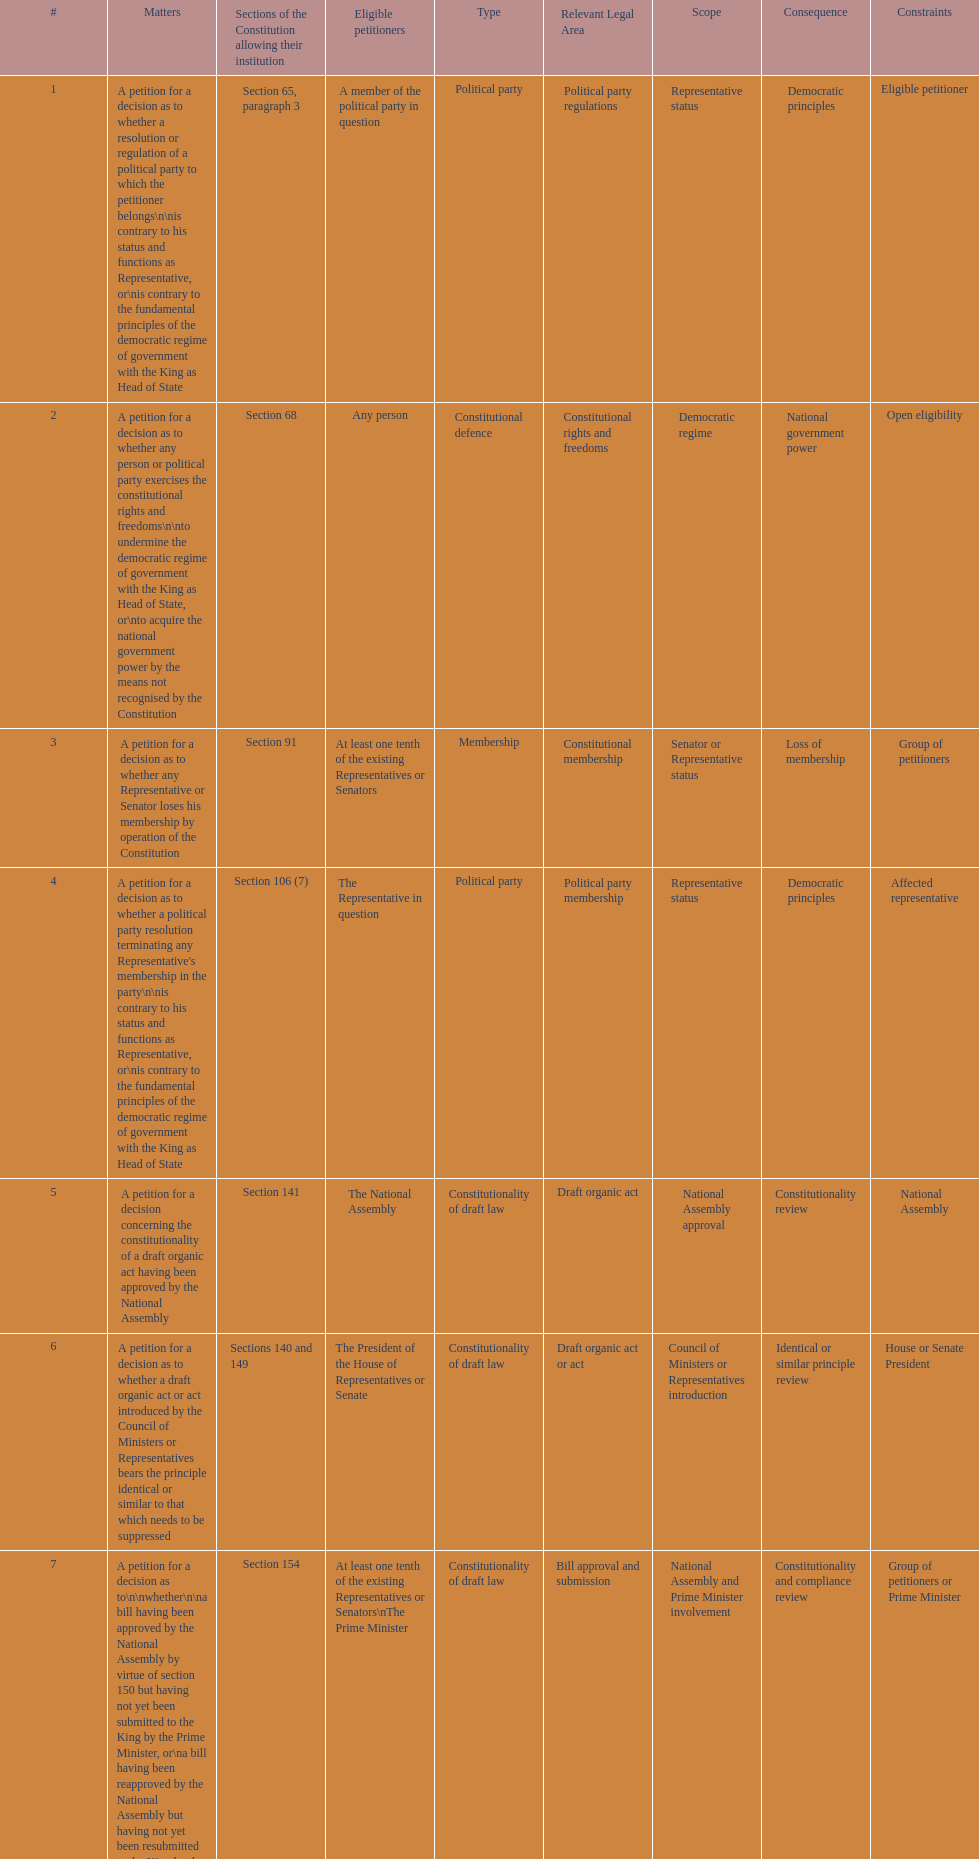Any person can petition matters 2 and 17. true or false? True. Give me the full table as a dictionary. {'header': ['#', 'Matters', 'Sections of the Constitution allowing their institution', 'Eligible petitioners', 'Type', 'Relevant Legal Area', 'Scope', 'Consequence', 'Constraints'], 'rows': [['1', 'A petition for a decision as to whether a resolution or regulation of a political party to which the petitioner belongs\\n\\nis contrary to his status and functions as Representative, or\\nis contrary to the fundamental principles of the democratic regime of government with the King as Head of State', 'Section 65, paragraph 3', 'A member of the political party in question', 'Political party', 'Political party regulations', 'Representative status', 'Democratic principles', 'Eligible petitioner'], ['2', 'A petition for a decision as to whether any person or political party exercises the constitutional rights and freedoms\\n\\nto undermine the democratic regime of government with the King as Head of State, or\\nto acquire the national government power by the means not recognised by the Constitution', 'Section 68', 'Any person', 'Constitutional defence', 'Constitutional rights and freedoms', 'Democratic regime', 'National government power', 'Open eligibility'], ['3', 'A petition for a decision as to whether any Representative or Senator loses his membership by operation of the Constitution', 'Section 91', 'At least one tenth of the existing Representatives or Senators', 'Membership', 'Constitutional membership', 'Senator or Representative status', 'Loss of membership', 'Group of petitioners'], ['4', "A petition for a decision as to whether a political party resolution terminating any Representative's membership in the party\\n\\nis contrary to his status and functions as Representative, or\\nis contrary to the fundamental principles of the democratic regime of government with the King as Head of State", 'Section 106 (7)', 'The Representative in question', 'Political party', 'Political party membership', 'Representative status', 'Democratic principles', 'Affected representative'], ['5', 'A petition for a decision concerning the constitutionality of a draft organic act having been approved by the National Assembly', 'Section 141', 'The National Assembly', 'Constitutionality of draft law', 'Draft organic act', 'National Assembly approval', 'Constitutionality review', 'National Assembly'], ['6', 'A petition for a decision as to whether a draft organic act or act introduced by the Council of Ministers or Representatives bears the principle identical or similar to that which needs to be suppressed', 'Sections 140 and 149', 'The President of the House of Representatives or Senate', 'Constitutionality of draft law', 'Draft organic act or act', 'Council of Ministers or Representatives introduction', 'Identical or similar principle review', 'House or Senate President'], ['7', 'A petition for a decision as to\\n\\nwhether\\n\\na bill having been approved by the National Assembly by virtue of section 150 but having not yet been submitted to the King by the Prime Minister, or\\na bill having been reapproved by the National Assembly but having not yet been resubmitted to the King by the Prime Minister,\\n\\n\\nis unconstitutional, or\\n\\n\\nwhether its enactment was in compliance with the requirements of the Constitution', 'Section 154', 'At least one tenth of the existing Representatives or Senators\\nThe Prime Minister', 'Constitutionality of draft law', 'Bill approval and submission', 'National Assembly and Prime Minister involvement', 'Constitutionality and compliance review', 'Group of petitioners or Prime Minister'], ['8', 'A petition for a decision as to\\n\\nwhether the draft rules of order of the House of Representatives, the draft rules of order of the Senate, or the draft rules of order of the National Assembly, which have been approved by the House of Representatives, Senate or National Assembly but have not yet been published in the Government Gazette, are unconstitutional, or\\nwhether their enactment was in compliance with the requirements of the Constitution', 'Section 155', 'At least one tenth of the existing Representatives or Senators\\nThe Prime Minister', 'Constitutionality of draft law', 'Draft rules of order', 'House, Senate or National Assembly approval', 'Constitutionality and compliance review', 'Group of petitioners or Prime Minister'], ['9', 'A petition for a decision as to whether any motion, motion amendment or action introduced during the House of Representatives, Senate or committee proceedings for consideration of a draft bill on annual expenditure budget, additional expenditure budget or expenditure budget transfer, would allow a Representative, Senator or committee member to directly or indirectly be involved in the disbursement of such budget', 'Section 168, paragraph 7', 'At least one tenth of the existing Representatives or Senators', 'Others', 'Budgetary proceedings', 'House, Senate or committee involvement', 'Involvement in budget disbursement', 'Group of petitioners'], ['10', 'A petition for a decision as to whether any Minister individually loses his ministership', 'Section 182', 'At least one tenth of the existing Representatives or Senators\\nThe Election Commission', 'Membership', 'Constitutional ministership', 'Minister status', 'Loss of ministership', 'Group of petitioners or Election Commission'], ['11', 'A petition for a decision as to whether an emergency decree is enacted against section 184, paragraph 1 or 2, of the Constitution', 'Section 185', 'At least one fifth of the existing Representatives or Senators', 'Constitutionality of law', 'Emergency decree', 'Constitutional enactment', 'Enactment review', 'Group of petitioners'], ['12', 'A petition for a decision as to whether any "written agreement" to be concluded by the Executive Branch requires prior parliamentary approval because\\n\\nit contains a provision which would bring about a change in the Thai territory or the extraterritorial areas over which Thailand is competent to exercise sovereignty or jurisdiction by virtue of a written agreement or international law,\\nits execution requires the enactment of an act,\\nit would extensively affect national economic or social security, or\\nit would considerably bind national trade, investment or budget', 'Section 190', 'At least one tenth of the existing Representatives or Senators', 'Authority', 'Written agreements', 'Executive Branch and Parliamentary approval', 'Agreement terms and impact', 'Group of petitioners'], ['13', 'A petition for a decision as to whether a legal provision to be applied to any case by a court of justice, administrative court or military court is unconstitutional', 'Section 211', 'A party to such case', 'Constitutionality of law', 'Legal provision in court case', 'Court of justice, administrative court or military court', 'Constitutionality review', 'Case party'], ['14', 'A petition for a decision as to the constitutionality of a legal provision', 'Section 212', 'Any person whose constitutionally recognised right or freedom has been violated', 'Constitutionality of law', 'Legal provision', 'Constitutional rights and freedoms', 'Constitutionality review', 'Affected person'], ['15', 'A petition for a decision as to a conflict of authority between the National Assembly, the Council of Ministers, or two or more constitutional organs other than the courts of justice, administrative courts or military courts', 'Section 214', 'The President of the National Assembly\\nThe Prime Minister\\nThe organs in question', 'Authority', 'Conflict of authority', 'National Assembly, Council of Ministers, or other constitutional organs', 'Authority resolution', 'Involved organ participant'], ['16', 'A petition for a decision as to whether any Election Commissioner lacks a qualification, is attacked by a disqualification or has committed a prohibited act', 'Section 233', 'At least one tenth of the existing Representatives or Senators', 'Membership', 'Election Commissioner eligibility', 'Commissioner status', 'Eligibility review', 'Group of petitioners'], ['17', 'A petition for\\n\\ndissolution of a political party deemed to have attempted to acquire the national government power by the means not recognised by the Constitution, and\\ndisfranchisement of its leader and executive members', 'Section 237 in conjunction with section 68', 'Any person', 'Political party', 'Political party dissolution', 'National government power acquisition', 'Dissolution and disfranchisement', 'Open eligibility'], ['18', 'A petition for a decision as to the constitutionality of any legal provision', 'Section 245 (1)', 'Ombudsmen', 'Constitutionality of law', 'Legal provision', 'Constitutional application', 'Constitutionality review', 'Ombudsman'], ['19', 'A petition for a decision as to the constitutionality of any legal provision on grounds of human rights', 'Section 257, paragraph 1 (2)', 'The National Human Rights Commission', 'Constitutionality of law', 'Legal provision', 'Human rights grounds', 'Constitutionality review', 'National Human Rights Commission'], ['20', 'Other matters permitted by legal provisions', '', '', 'Others', 'Varies', 'Varies', 'Varies', 'Legal provision permitting']]} 